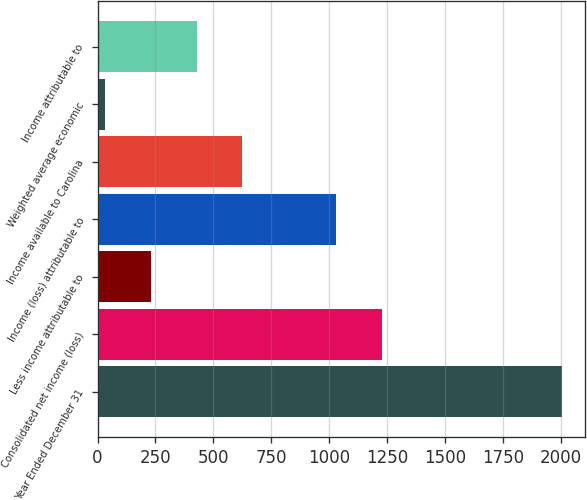<chart> <loc_0><loc_0><loc_500><loc_500><bar_chart><fcel>Year Ended December 31<fcel>Consolidated net income (loss)<fcel>Less income attributable to<fcel>Income (loss) attributable to<fcel>Income available to Carolina<fcel>Weighted average economic<fcel>Income attributable to<nl><fcel>2004<fcel>1228.32<fcel>230.82<fcel>1031.3<fcel>624.86<fcel>33.8<fcel>427.84<nl></chart> 